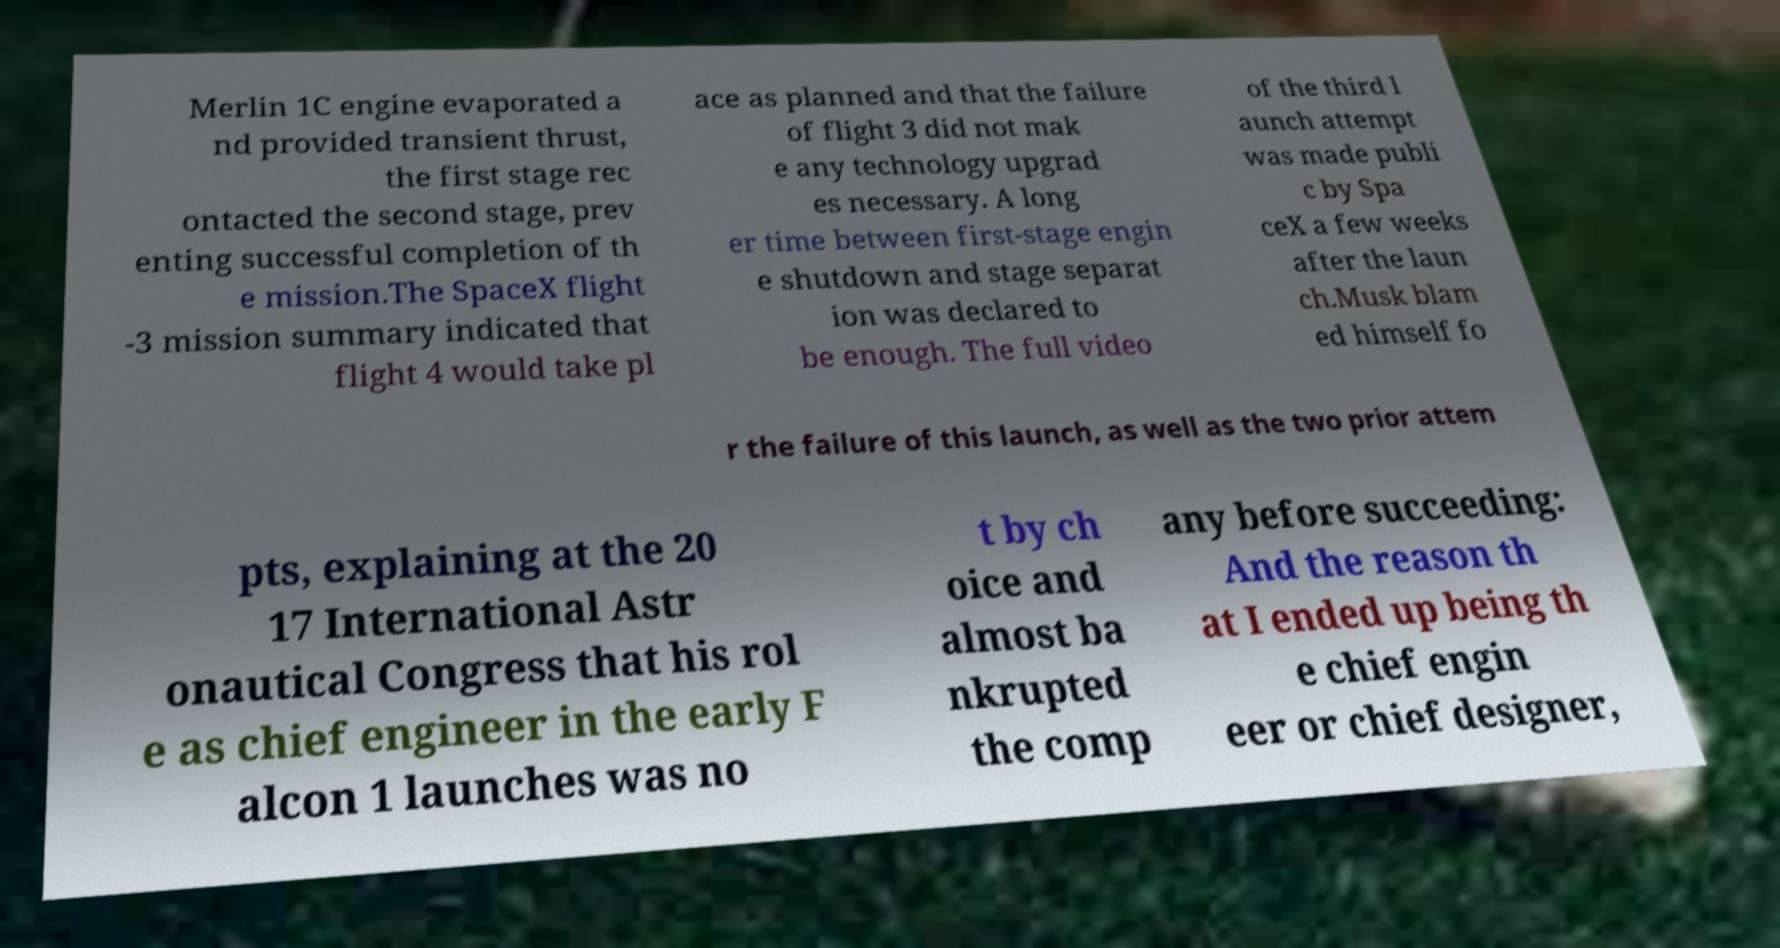Can you read and provide the text displayed in the image?This photo seems to have some interesting text. Can you extract and type it out for me? Merlin 1C engine evaporated a nd provided transient thrust, the first stage rec ontacted the second stage, prev enting successful completion of th e mission.The SpaceX flight -3 mission summary indicated that flight 4 would take pl ace as planned and that the failure of flight 3 did not mak e any technology upgrad es necessary. A long er time between first-stage engin e shutdown and stage separat ion was declared to be enough. The full video of the third l aunch attempt was made publi c by Spa ceX a few weeks after the laun ch.Musk blam ed himself fo r the failure of this launch, as well as the two prior attem pts, explaining at the 20 17 International Astr onautical Congress that his rol e as chief engineer in the early F alcon 1 launches was no t by ch oice and almost ba nkrupted the comp any before succeeding: And the reason th at I ended up being th e chief engin eer or chief designer, 